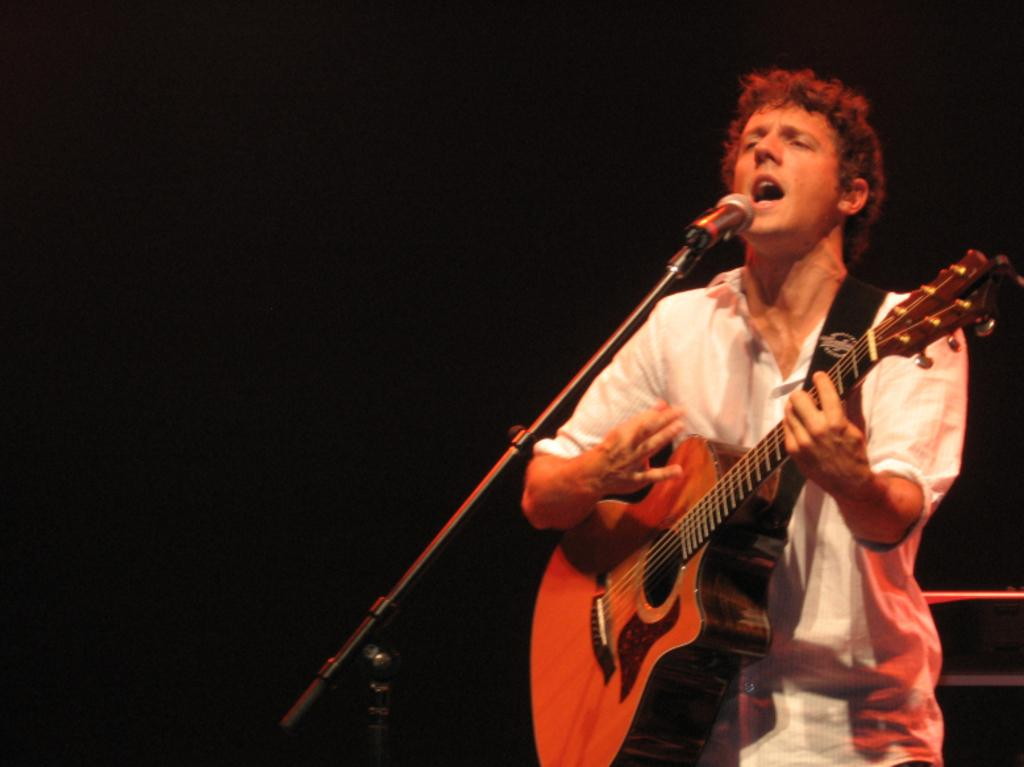Who is the main subject in the image? There is a man in the image. What is the man doing in the image? The man is singing and playing a guitar. What object is the man holding in the image? The man is holding a microphone. What color is the man's sweater in the image? There is no mention of a sweater in the image, so we cannot determine its color. 